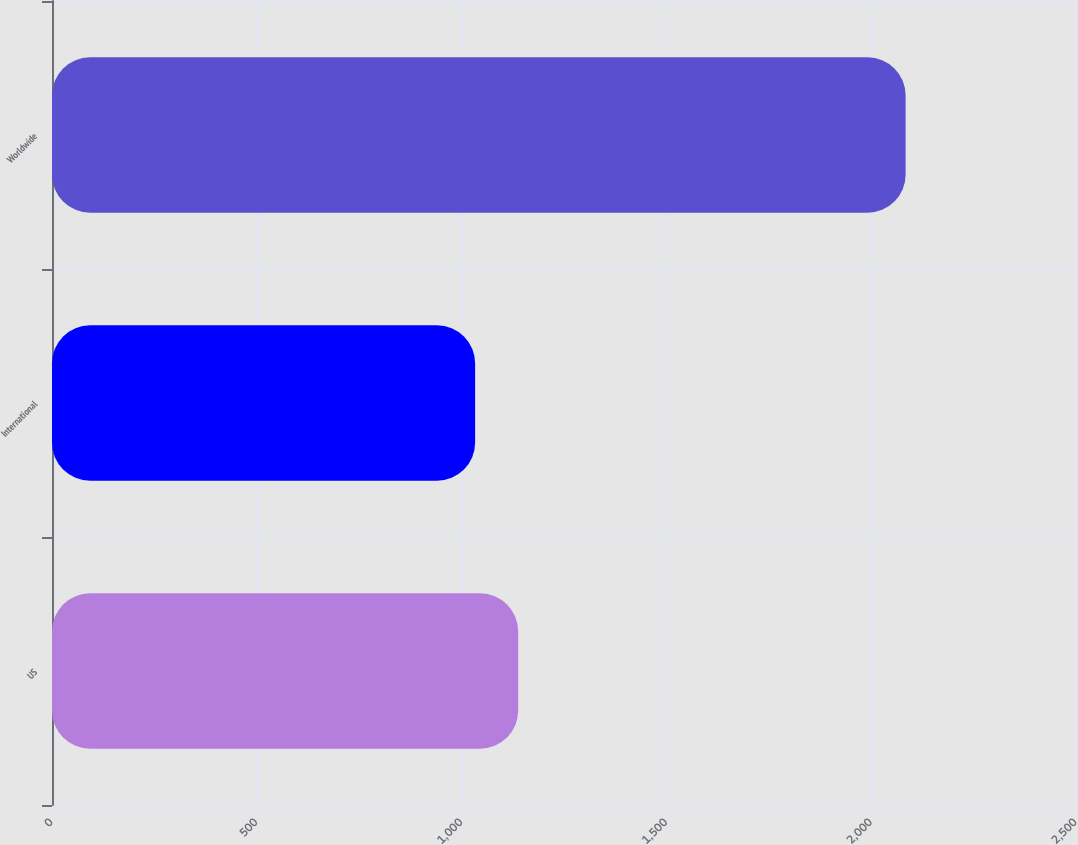Convert chart. <chart><loc_0><loc_0><loc_500><loc_500><bar_chart><fcel>US<fcel>International<fcel>Worldwide<nl><fcel>1138.1<fcel>1033<fcel>2084<nl></chart> 